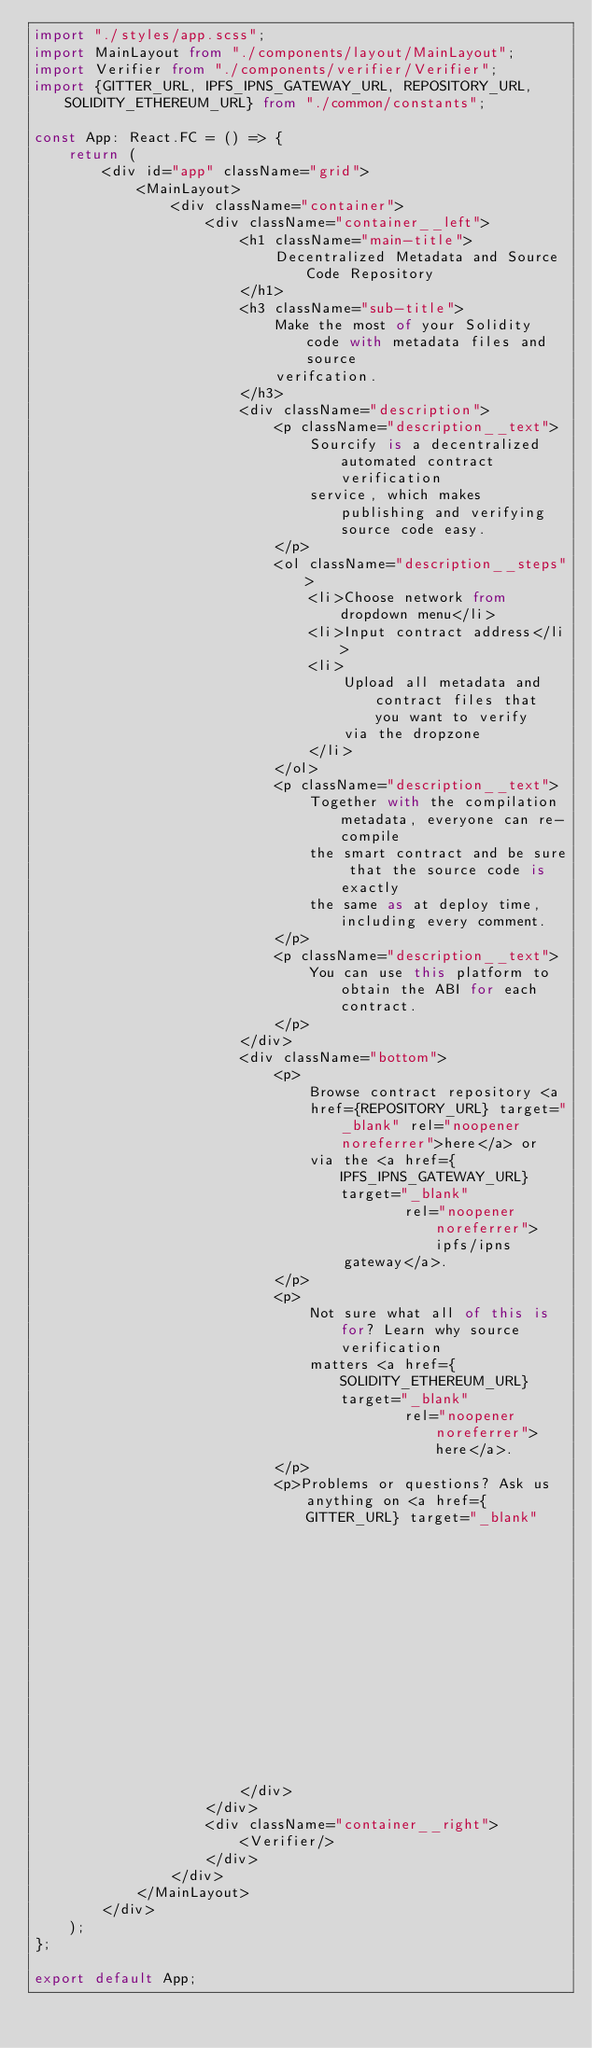Convert code to text. <code><loc_0><loc_0><loc_500><loc_500><_TypeScript_>import "./styles/app.scss";
import MainLayout from "./components/layout/MainLayout";
import Verifier from "./components/verifier/Verifier";
import {GITTER_URL, IPFS_IPNS_GATEWAY_URL, REPOSITORY_URL, SOLIDITY_ETHEREUM_URL} from "./common/constants";

const App: React.FC = () => {
    return (
        <div id="app" className="grid">
            <MainLayout>
                <div className="container">
                    <div className="container__left">
                        <h1 className="main-title">
                            Decentralized Metadata and Source Code Repository
                        </h1>
                        <h3 className="sub-title">
                            Make the most of your Solidity code with metadata files and source
                            verifcation.
                        </h3>
                        <div className="description">
                            <p className="description__text">
                                Sourcify is a decentralized automated contract verification
                                service, which makes publishing and verifying source code easy.
                            </p>
                            <ol className="description__steps">
                                <li>Choose network from dropdown menu</li>
                                <li>Input contract address</li>
                                <li>
                                    Upload all metadata and contract files that you want to verify
                                    via the dropzone
                                </li>
                            </ol>
                            <p className="description__text">
                                Together with the compilation metadata, everyone can re-compile
                                the smart contract and be sure that the source code is exactly
                                the same as at deploy time, including every comment.
                            </p>
                            <p className="description__text">
                                You can use this platform to obtain the ABI for each contract.
                            </p>
                        </div>
                        <div className="bottom">
                            <p>
                                Browse contract repository <a
                                href={REPOSITORY_URL} target="_blank" rel="noopener noreferrer">here</a> or
                                via the <a href={IPFS_IPNS_GATEWAY_URL} target="_blank"
                                           rel="noopener noreferrer">ipfs/ipns
                                    gateway</a>.
                            </p>
                            <p>
                                Not sure what all of this is for? Learn why source verification
                                matters <a href={SOLIDITY_ETHEREUM_URL} target="_blank"
                                           rel="noopener noreferrer">here</a>.
                            </p>
                            <p>Problems or questions? Ask us anything on <a href={GITTER_URL} target="_blank"
                                                                            rel="noopener noreferrer">Gitter!</a></p>
                        </div>
                    </div>
                    <div className="container__right">
                        <Verifier/>
                    </div>
                </div>
            </MainLayout>
        </div>
    );
};

export default App;
</code> 